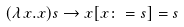<formula> <loc_0><loc_0><loc_500><loc_500>( \lambda x . x ) s \to x [ x \colon = s ] = s</formula> 